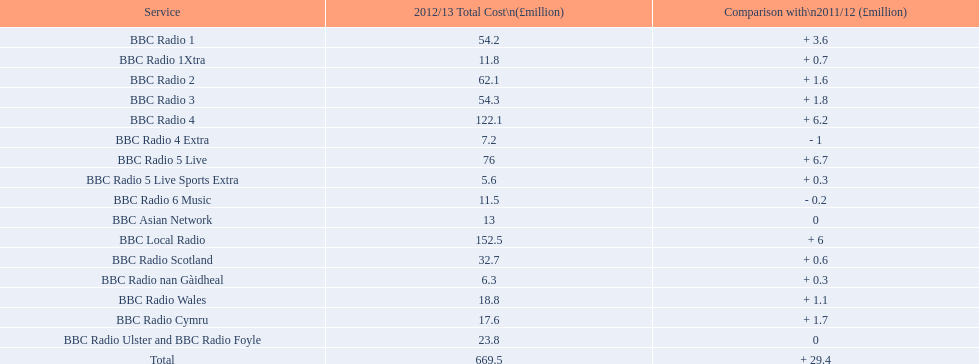What was the highest expenditure for operating a station in 2012/13? 152.5. Which station had a running cost of £152.5 million during this period? BBC Local Radio. 